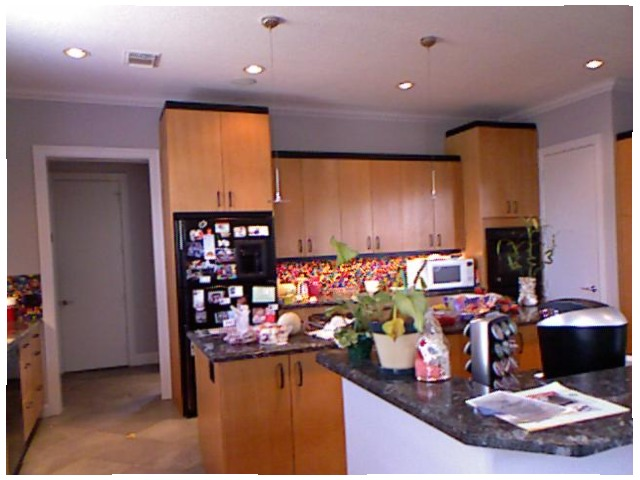<image>
Can you confirm if the plant is in the counter? Yes. The plant is contained within or inside the counter, showing a containment relationship. 